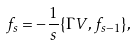<formula> <loc_0><loc_0><loc_500><loc_500>f _ { s } = - \frac { 1 } { s } \{ \Gamma V , f _ { s - 1 } \} ,</formula> 